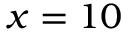Convert formula to latex. <formula><loc_0><loc_0><loc_500><loc_500>x = 1 0</formula> 